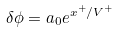Convert formula to latex. <formula><loc_0><loc_0><loc_500><loc_500>\delta \phi = a _ { 0 } e ^ { x ^ { + } / V ^ { + } }</formula> 